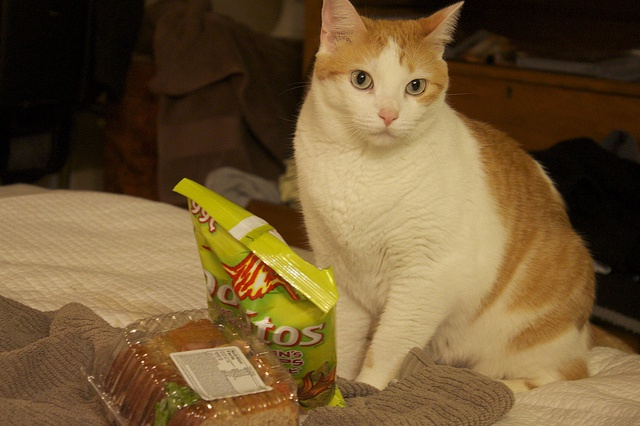Describe the objects in this image and their specific colors. I can see cat in black, tan, and olive tones, bed in black, tan, olive, and gray tones, cake in black, brown, maroon, and tan tones, and sandwich in black, brown, maroon, and tan tones in this image. 